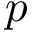<formula> <loc_0><loc_0><loc_500><loc_500>p</formula> 